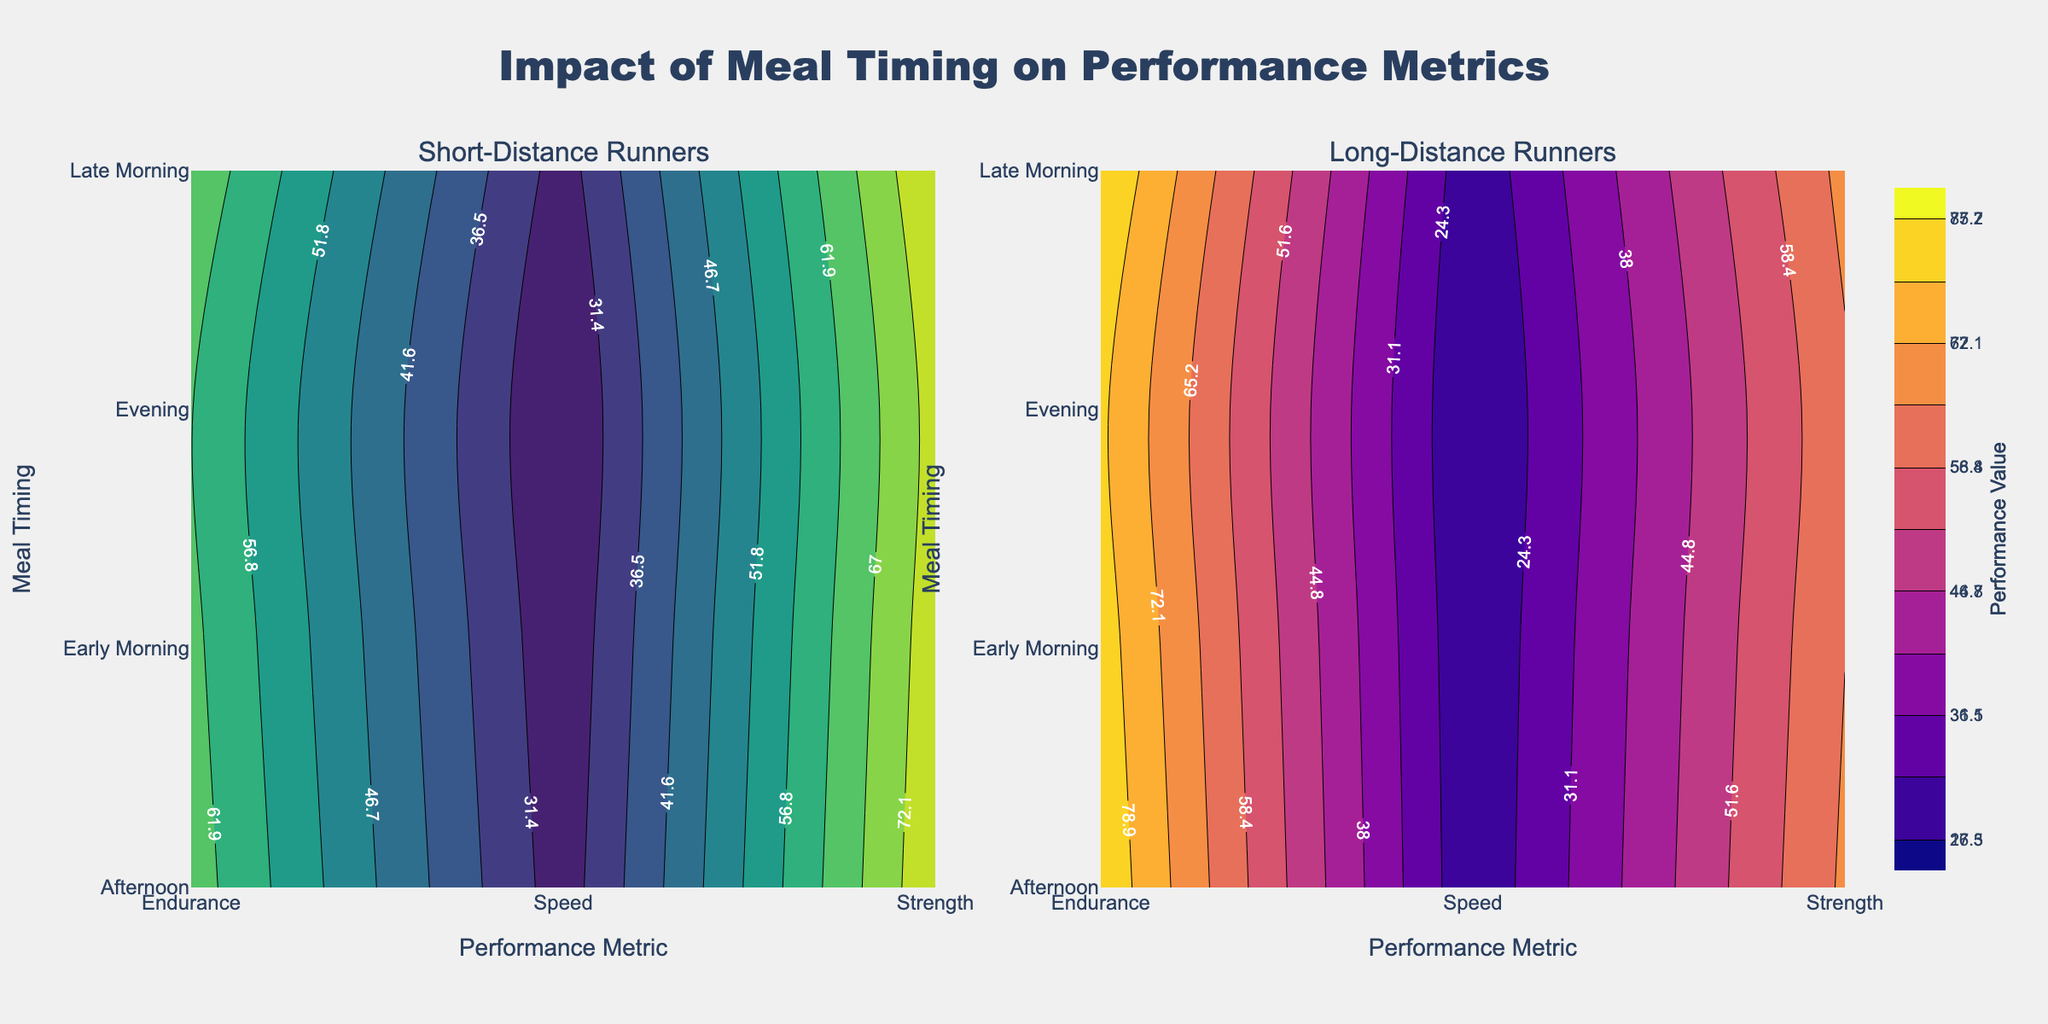Which runner type shows the highest speed performance with early morning meals? In the contour plot for Short-Distance Runners, the highest speed value for early morning meals is 27.5, while for Long-Distance Runners, it is 18.4. Therefore, the highest speed performance with early morning meals is observed in Short-Distance Runners.
Answer: Short-Distance Runners Which meal timing results in the highest strength for long-distance runners? On the subplot for Long-Distance Runners, the highest strength value is observed for the Late Morning meal timing, which is 67.3.
Answer: Late Morning Is there a specific meal timing that results in the lowest endurance for both short-distance and long-distance runners? In the plot for Short-Distance Runners, the lowest endurance value is 62.1 for the Evening meal timing. In the plot for Long-Distance Runners, the lowest endurance value is 80.2 for the Evening meal timing. Both runner types show the lowest endurance in the evening.
Answer: Evening Compare the impact of the Late Morning meal on speed performance for short-distance vs. long-distance runners. The Late Morning meal timing shows a speed value of 29.1 for Short-Distance Runners and 19.6 for Long-Distance Runners. By comparing these values, Speed performance is higher in Short-Distance Runners for Late Morning meals.
Answer: Short-Distance Runners What is the difference in strength performance between early morning and evening meals for short-distance runners? The strength value for Early Morning meals is 75.3 and 74.2 for Evening meals. The difference is calculated as 75.3 - 74.2 = 1.1.
Answer: 1.1 Which performance metric shows the highest variability across different meal timings for long-distance runners? By visually assessing the contour plot for Long-Distance Runners, the performance metric showing the highest range of values across meal timings is Endurance, varying from 80.2 to 85.7, whereas Speed and Strength have more limited variations.
Answer: Endurance How does the speed performance of short-distance runners change from the Afternoon to the Evening meal? In the plot for Short-Distance Runners, the speed value for Afternoon is 28.7, and for Evening, it is 26.3. The change in speed performance is 28.7 - 26.3 = 2.4.
Answer: 2.4 What are the meal timings that show the peak performance in strength for both short-distance and long-distance runners? For Short-Distance Runners, the peak strength value is 77.2 during the Late Morning meal timing. For Long-Distance Runners, the peak strength value is 67.3 during the Late Morning meal timing. Both runner types show peak strength in the Late Morning.
Answer: Late Morning 